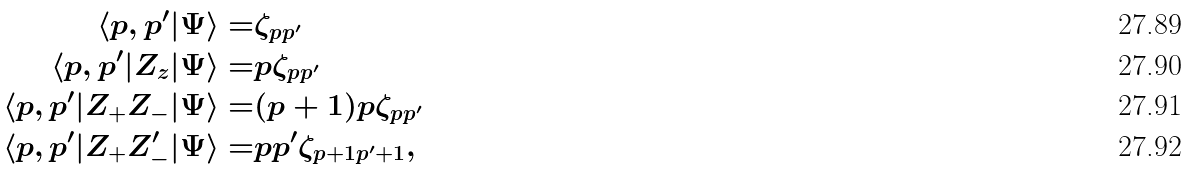Convert formula to latex. <formula><loc_0><loc_0><loc_500><loc_500>\langle p , p ^ { \prime } | \Psi \rangle = & \zeta _ { p p ^ { \prime } } \\ \langle p , p ^ { \prime } | Z _ { z } | \Psi \rangle = & p \zeta _ { p p ^ { \prime } } \\ \langle p , p ^ { \prime } | Z _ { + } Z _ { - } | \Psi \rangle = & ( p + 1 ) p \zeta _ { p p ^ { \prime } } \\ \langle p , p ^ { \prime } | Z _ { + } Z _ { - } ^ { \prime } | \Psi \rangle = & p p ^ { \prime } \zeta _ { p + 1 p ^ { \prime } + 1 } ,</formula> 